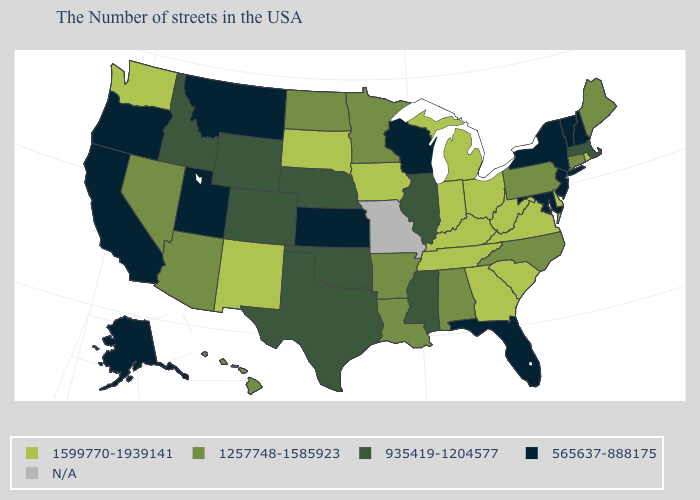What is the value of Oregon?
Short answer required. 565637-888175. What is the value of Arizona?
Quick response, please. 1257748-1585923. Among the states that border Pennsylvania , which have the highest value?
Answer briefly. Delaware, West Virginia, Ohio. Among the states that border Rhode Island , does Connecticut have the highest value?
Quick response, please. Yes. Name the states that have a value in the range 1257748-1585923?
Keep it brief. Maine, Connecticut, Pennsylvania, North Carolina, Alabama, Louisiana, Arkansas, Minnesota, North Dakota, Arizona, Nevada, Hawaii. What is the value of Utah?
Keep it brief. 565637-888175. Name the states that have a value in the range N/A?
Quick response, please. Missouri. Does the map have missing data?
Concise answer only. Yes. Name the states that have a value in the range 1599770-1939141?
Answer briefly. Rhode Island, Delaware, Virginia, South Carolina, West Virginia, Ohio, Georgia, Michigan, Kentucky, Indiana, Tennessee, Iowa, South Dakota, New Mexico, Washington. What is the value of North Carolina?
Keep it brief. 1257748-1585923. What is the lowest value in the USA?
Write a very short answer. 565637-888175. Which states have the highest value in the USA?
Quick response, please. Rhode Island, Delaware, Virginia, South Carolina, West Virginia, Ohio, Georgia, Michigan, Kentucky, Indiana, Tennessee, Iowa, South Dakota, New Mexico, Washington. What is the value of Rhode Island?
Concise answer only. 1599770-1939141. What is the lowest value in states that border California?
Write a very short answer. 565637-888175. Does Maryland have the lowest value in the USA?
Quick response, please. Yes. 